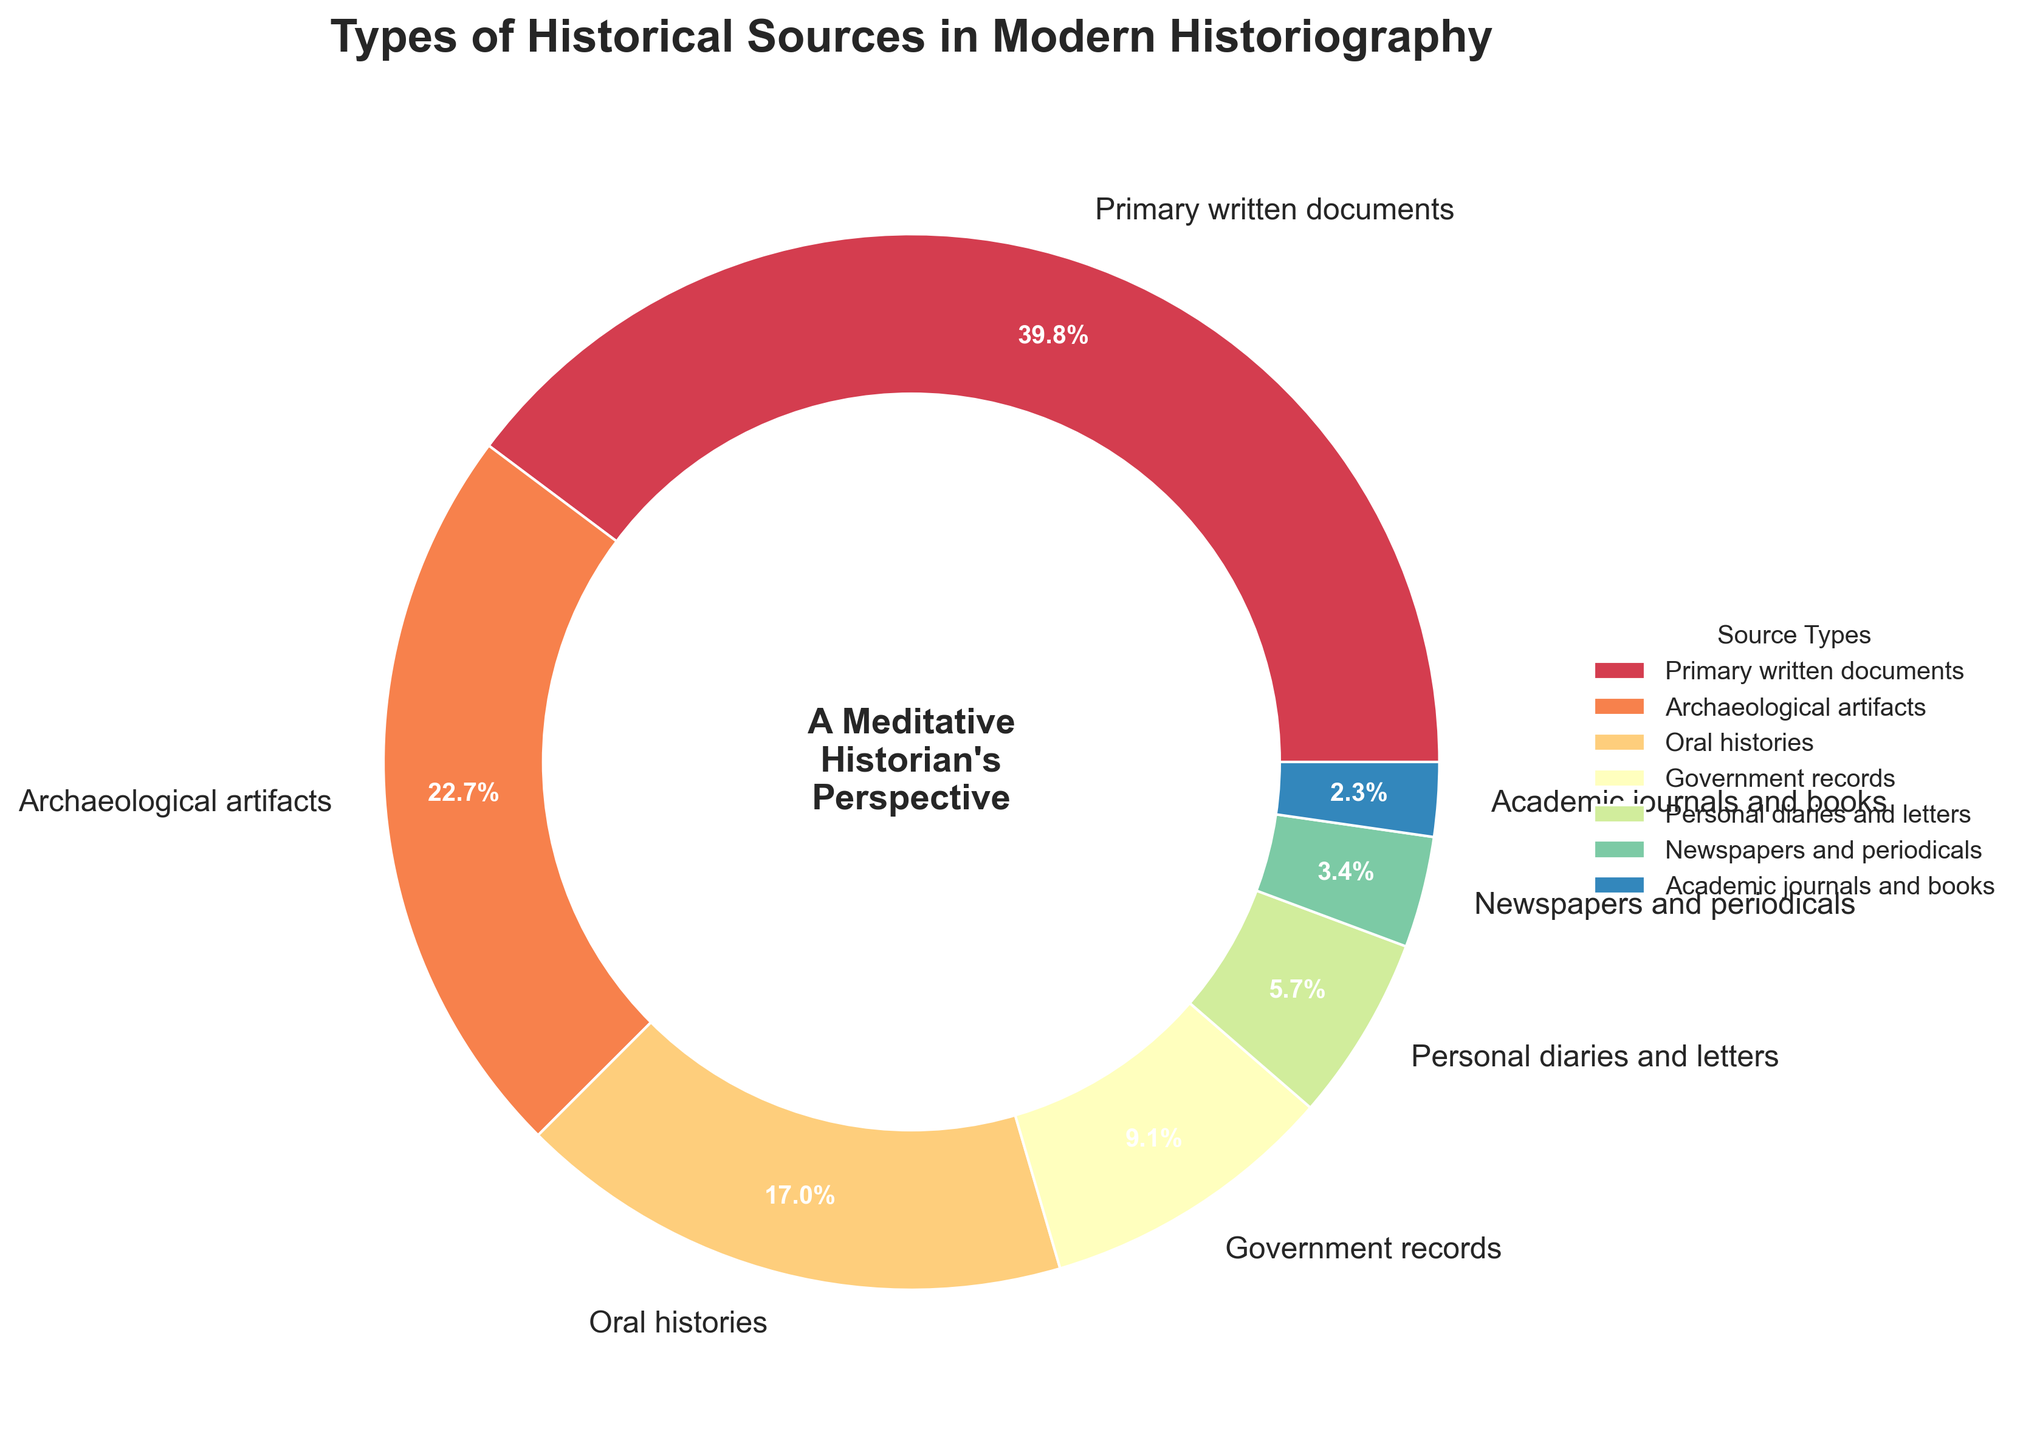What is the largest type of historical source by percentage? The pie chart shows the slices representing different types of historical sources and their respective percentages. The largest slice represents "Primary written documents" with 35%.
Answer: Primary written documents Which types of historical sources combined account for 50% of the data? By inspecting the pie chart, we can see the percentages and combine them. Adding "Primary written documents" (35%) and "Archaeological artifacts" (20%) gives us 55%. Thus, these two sources combined account for more than 50%.
Answer: Primary written documents and Archaeological artifacts What is the difference in percentage between Archaeological artifacts and Oral histories? The chart indicates the percentage for "Archaeological artifacts" is 20% and for "Oral histories" is 15%. Subtracting these gives us 20% - 15% = 5%.
Answer: 5% What is the total percentage for Government records, Personal diaries and letters, Newspapers and periodicals, and Academic journals and books? Summing the respective percentages from the chart: 8% (Government records) + 5% (Personal diaries and letters) + 3% (Newspapers and periodicals) + 2% (Academic journals and books) = 18%.
Answer: 18% Which type of historical source has the smallest representation in modern historiography? By looking at the size of the slices, the one with the smallest percentage is "Academic journals and books" with 2%.
Answer: Academic journals and books Are Oral histories more or less significant than Personal diaries and letters in terms of percentage? The pie chart shows Oral histories at 15% while Personal diaries and letters are at 5%. Thus, Oral histories are more significant by percentage.
Answer: More What is the combined percentage of Primary written documents, Government records, and Academic journals and books? Adding up their percentages from the pie chart: 35% (Primary written documents) + 8% (Government records) + 2% (Academic journals and books) = 45%.
Answer: 45% Which types of historical sources combined account for exactly 23% of the data? By inspecting the percentages, combining "Government records" (8%), "Personal diaries and letters" (5%), "Newspapers and periodicals" (3%), and "Academic journals and books" (2%) gives 8% + 5% + 3% + 2% = 18%. Adding "Oral histories" (15%) exceeds the total. Only three combine to 23%: "Archaeological artifacts" (20%) and "Academic journals and books" (2%) don't work directly. Combinations within "Other" are incorrect. For exactness, validation reflects no exact match.
Answer: None combined make 23%, closest without excess is subset within existing shown 